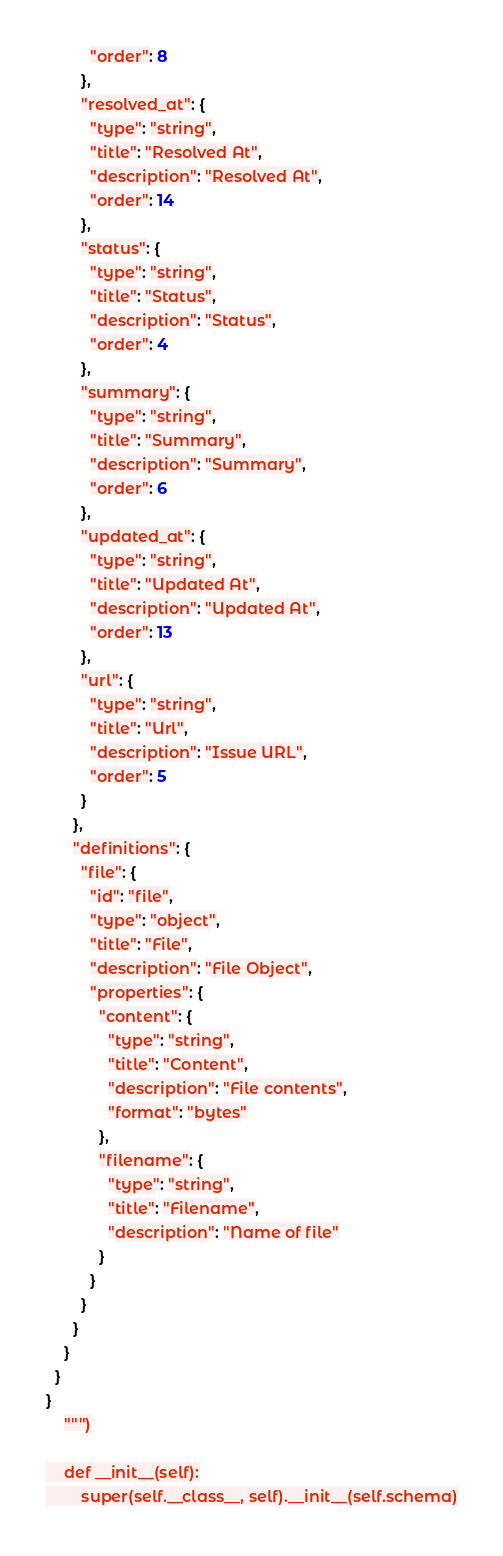Convert code to text. <code><loc_0><loc_0><loc_500><loc_500><_Python_>          "order": 8
        },
        "resolved_at": {
          "type": "string",
          "title": "Resolved At",
          "description": "Resolved At",
          "order": 14
        },
        "status": {
          "type": "string",
          "title": "Status",
          "description": "Status",
          "order": 4
        },
        "summary": {
          "type": "string",
          "title": "Summary",
          "description": "Summary",
          "order": 6
        },
        "updated_at": {
          "type": "string",
          "title": "Updated At",
          "description": "Updated At",
          "order": 13
        },
        "url": {
          "type": "string",
          "title": "Url",
          "description": "Issue URL",
          "order": 5
        }
      },
      "definitions": {
        "file": {
          "id": "file",
          "type": "object",
          "title": "File",
          "description": "File Object",
          "properties": {
            "content": {
              "type": "string",
              "title": "Content",
              "description": "File contents",
              "format": "bytes"
            },
            "filename": {
              "type": "string",
              "title": "Filename",
              "description": "Name of file"
            }
          }
        }
      }
    }
  }
}
    """)

    def __init__(self):
        super(self.__class__, self).__init__(self.schema)
</code> 